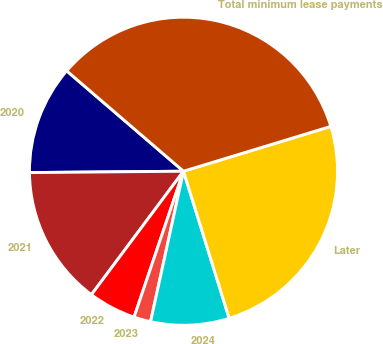Convert chart to OTSL. <chart><loc_0><loc_0><loc_500><loc_500><pie_chart><fcel>2020<fcel>2021<fcel>2022<fcel>2023<fcel>2024<fcel>Later<fcel>Total minimum lease payments<nl><fcel>11.44%<fcel>14.66%<fcel>5.0%<fcel>1.77%<fcel>8.22%<fcel>24.91%<fcel>34.0%<nl></chart> 